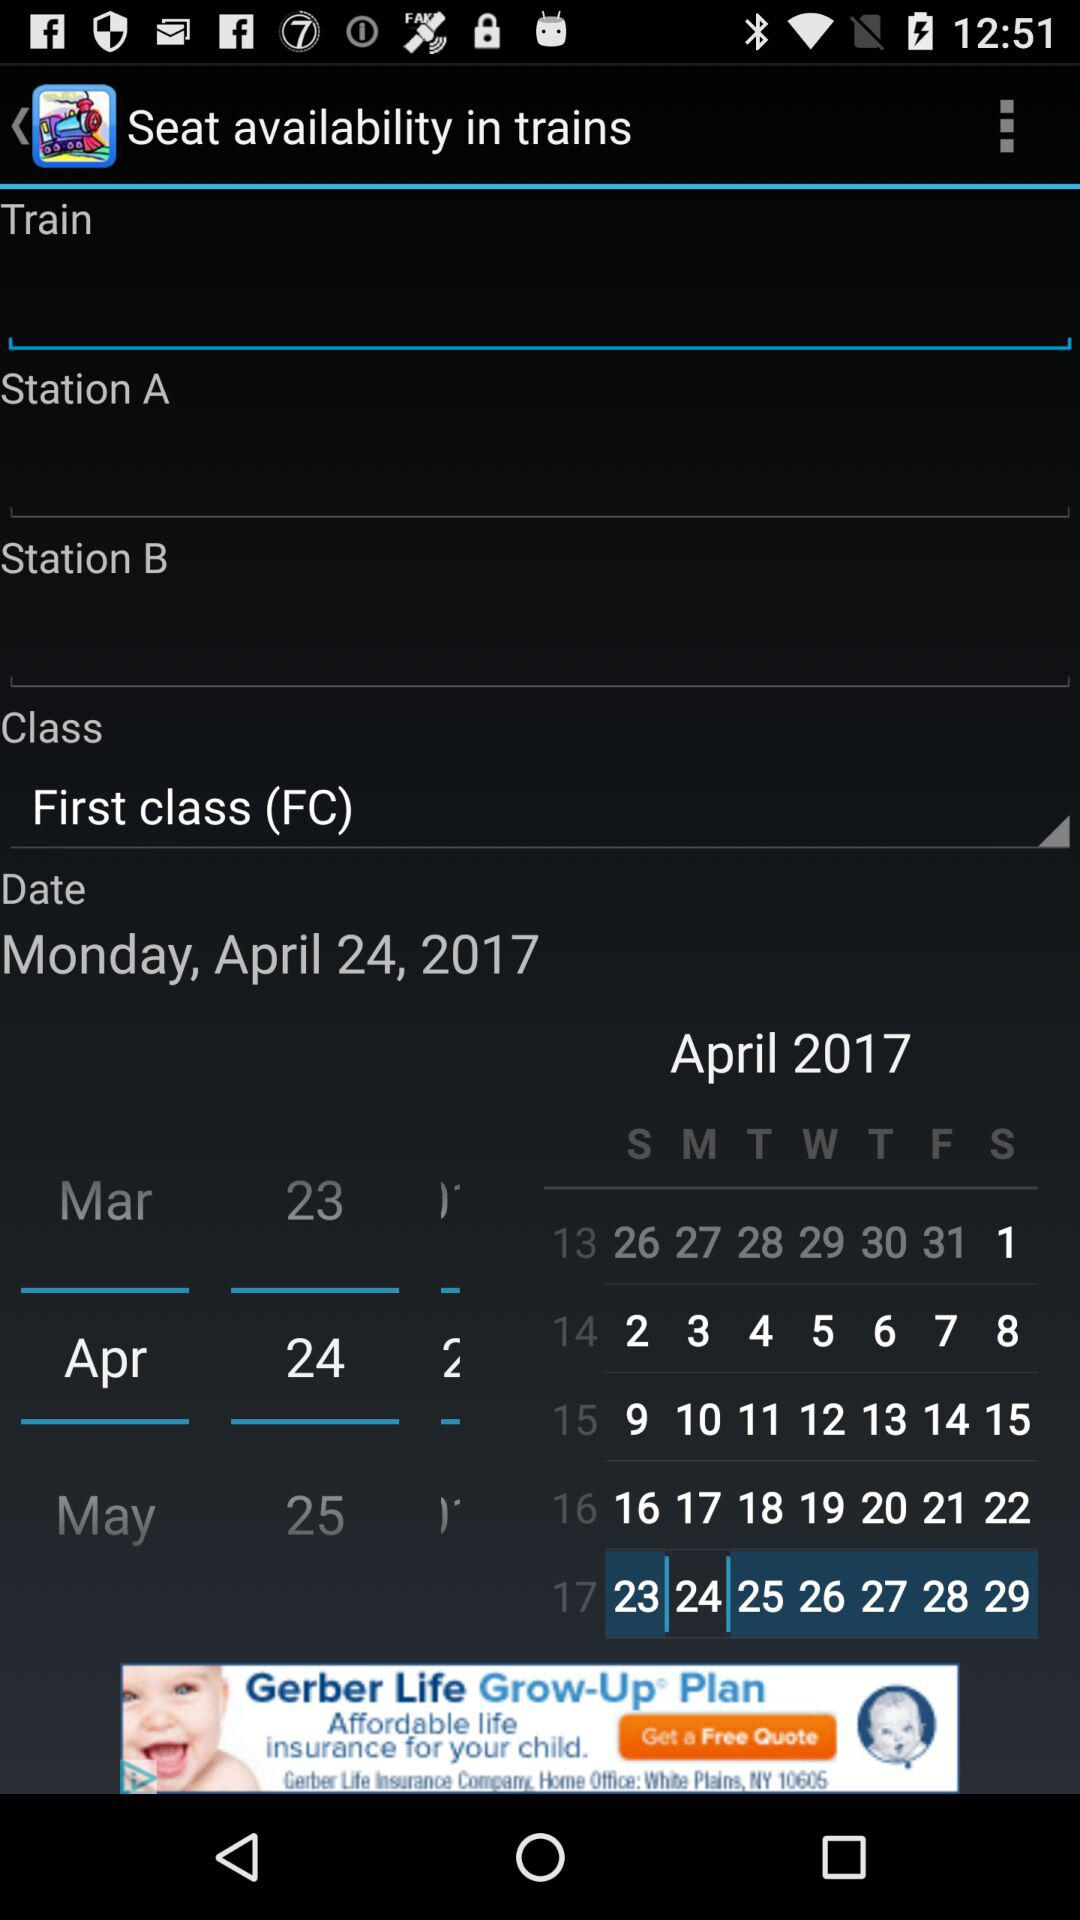What date is selected? The selected date is Monday, April 24, 2017. 